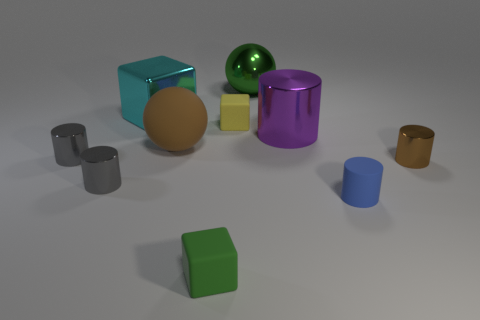There is a rubber object that is the same color as the big shiny sphere; what is its size?
Provide a succinct answer. Small. What shape is the tiny matte object that is the same color as the metallic sphere?
Offer a terse response. Cube. What color is the other tiny matte object that is the same shape as the small brown thing?
Provide a short and direct response. Blue. Does the purple object have the same material as the blue cylinder?
Make the answer very short. No. There is a tiny cube behind the green matte object; what number of tiny cubes are right of it?
Keep it short and to the point. 0. Are there any blue things of the same shape as the purple metallic object?
Keep it short and to the point. Yes. There is a tiny rubber object that is behind the tiny blue rubber cylinder; does it have the same shape as the tiny gray metal object that is behind the small brown cylinder?
Provide a succinct answer. No. What is the shape of the shiny thing that is right of the cyan metal cube and in front of the purple cylinder?
Ensure brevity in your answer.  Cylinder. Are there any purple cylinders of the same size as the green rubber block?
Offer a terse response. No. Does the rubber sphere have the same color as the small metal cylinder that is on the right side of the green rubber object?
Offer a terse response. Yes. 